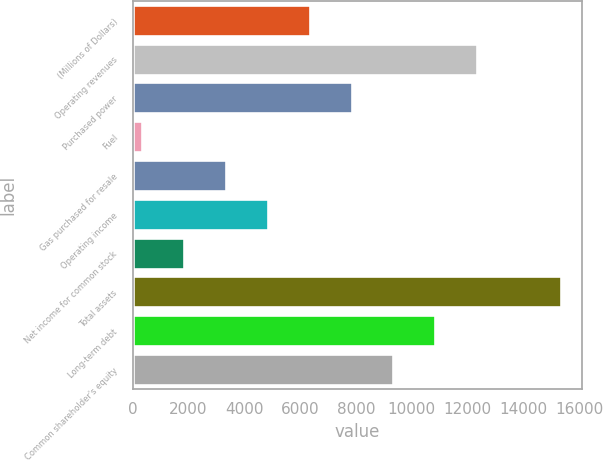Convert chart to OTSL. <chart><loc_0><loc_0><loc_500><loc_500><bar_chart><fcel>(Millions of Dollars)<fcel>Operating revenues<fcel>Purchased power<fcel>Fuel<fcel>Gas purchased for resale<fcel>Operating income<fcel>Net income for common stock<fcel>Total assets<fcel>Long-term debt<fcel>Common shareholder's equity<nl><fcel>6349.4<fcel>12347.8<fcel>7849<fcel>351<fcel>3350.2<fcel>4849.8<fcel>1850.6<fcel>15347<fcel>10848.2<fcel>9348.6<nl></chart> 